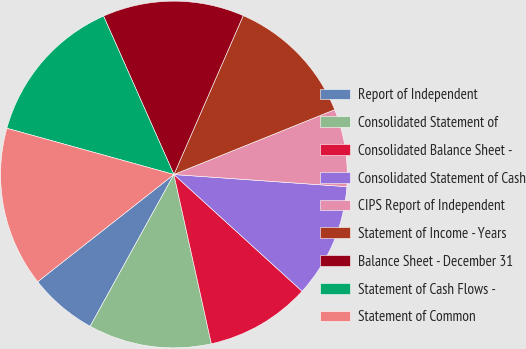Convert chart. <chart><loc_0><loc_0><loc_500><loc_500><pie_chart><fcel>Report of Independent<fcel>Consolidated Statement of<fcel>Consolidated Balance Sheet -<fcel>Consolidated Statement of Cash<fcel>CIPS Report of Independent<fcel>Statement of Income - Years<fcel>Balance Sheet - December 31<fcel>Statement of Cash Flows -<fcel>Statement of Common<nl><fcel>6.36%<fcel>11.49%<fcel>9.78%<fcel>10.64%<fcel>7.22%<fcel>12.35%<fcel>13.2%<fcel>14.05%<fcel>14.91%<nl></chart> 